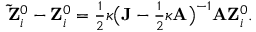Convert formula to latex. <formula><loc_0><loc_0><loc_500><loc_500>\begin{array} { r } { { \tilde { Z } } _ { i } ^ { 0 } - { Z } _ { i } ^ { 0 } = \frac { 1 } { 2 } \kappa \left ( { J } - \frac { 1 } { 2 } \kappa { A } \right ) ^ { - 1 } { A } { Z } _ { i } ^ { 0 } . } \end{array}</formula> 